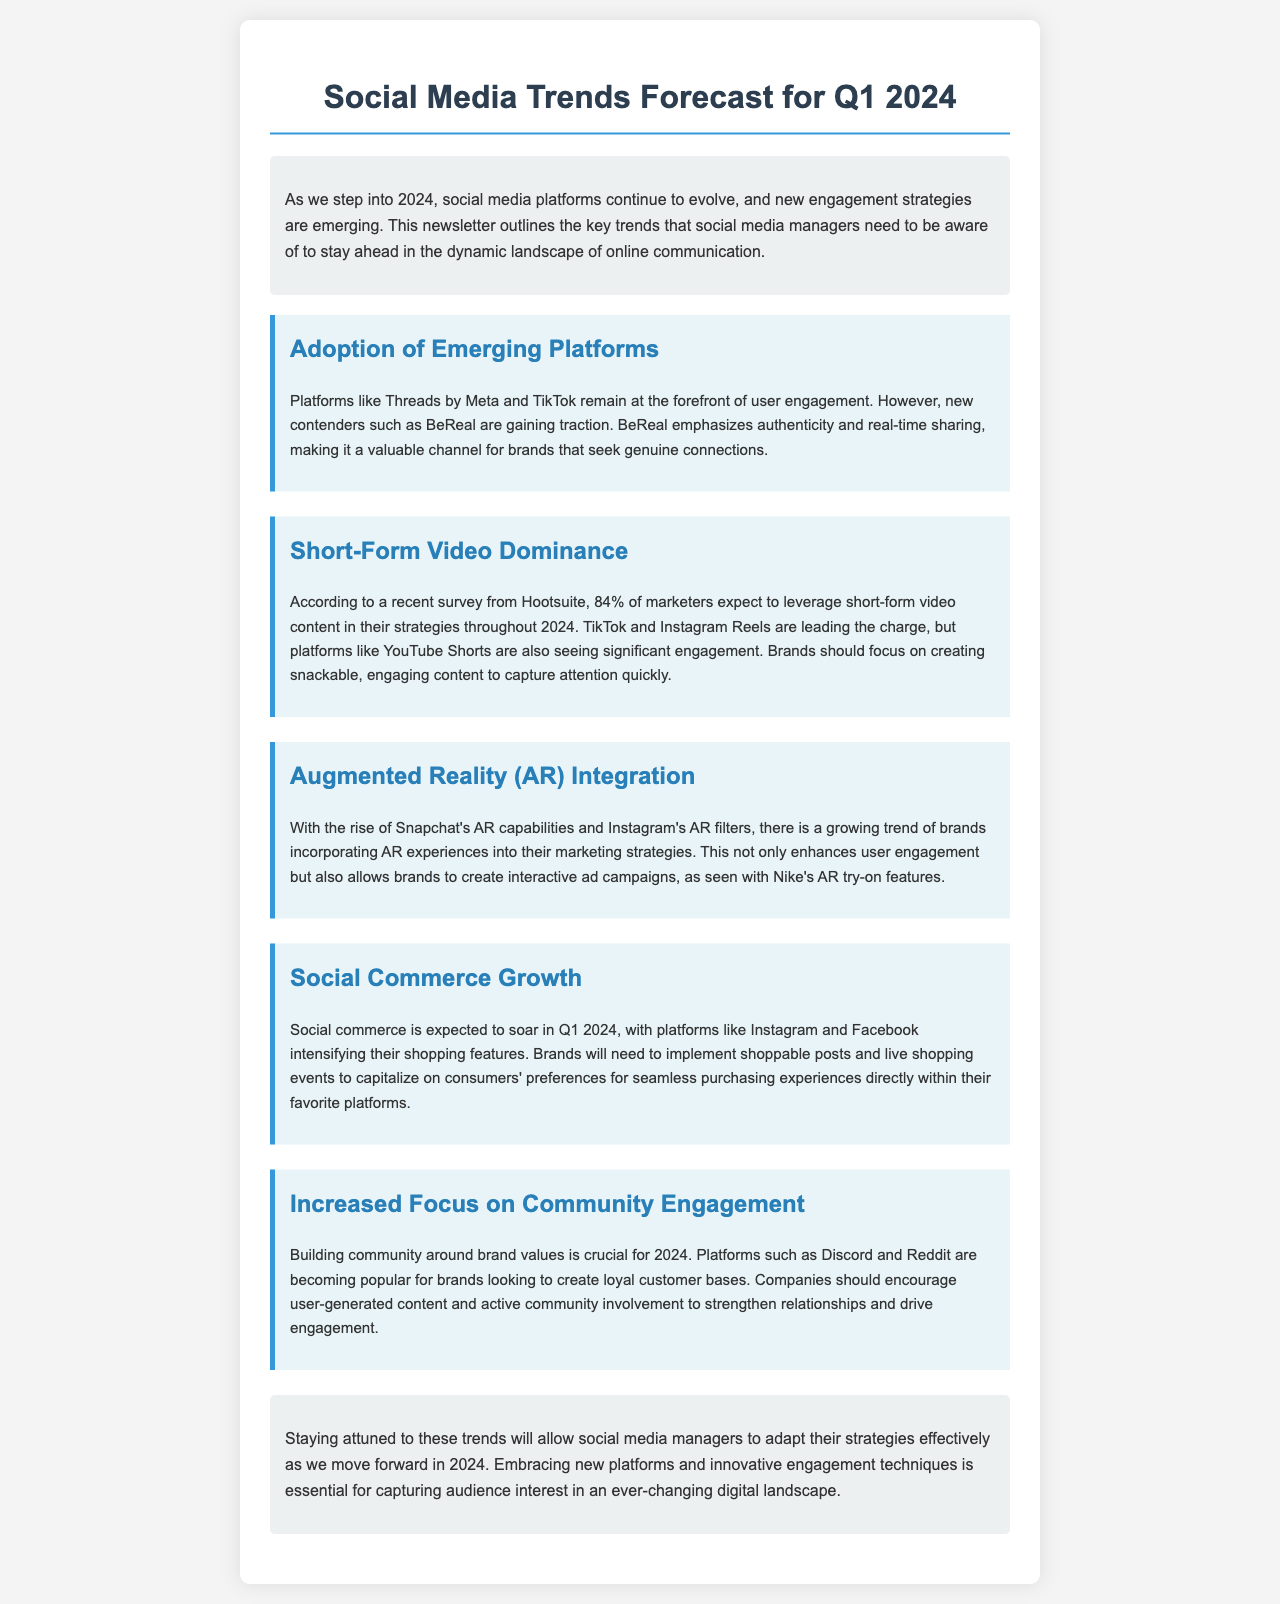What are the emerging platforms highlighted? The document mentions emerging platforms like Threads by Meta, TikTok, and BeReal in the context of user engagement.
Answer: Threads by Meta, TikTok, BeReal What percentage of marketers expect to use short-form video content? The document states that according to Hootsuite, 84% of marketers expect to leverage short-form video content in 2024.
Answer: 84% Which platform is noted for its AR capabilities? The document highlights Snapchat's AR capabilities as a significant trend in incorporating augmented reality into marketing strategies.
Answer: Snapchat What is expected to soar in Q1 2024? The document mentions that social commerce is expected to soar in Q1 2024, particularly on platforms like Instagram and Facebook.
Answer: Social commerce Which platforms are becoming popular for community engagement? The document states that platforms such as Discord and Reddit are popular for brands looking to create loyal customer bases through community engagement.
Answer: Discord, Reddit What kind of content should brands focus on creating? The document specifies that brands should focus on creating snackable, engaging content to capture audience attention quickly.
Answer: Snackable, engaging content What is crucial for 2024 according to the document? The document emphasizes that building community around brand values is crucial for 2024.
Answer: Building community around brand values What interactive feature did Nike utilize in its marketing strategy? The document cites Nike's AR try-on features as an example of incorporating AR experiences into marketing strategies.
Answer: AR try-on features 